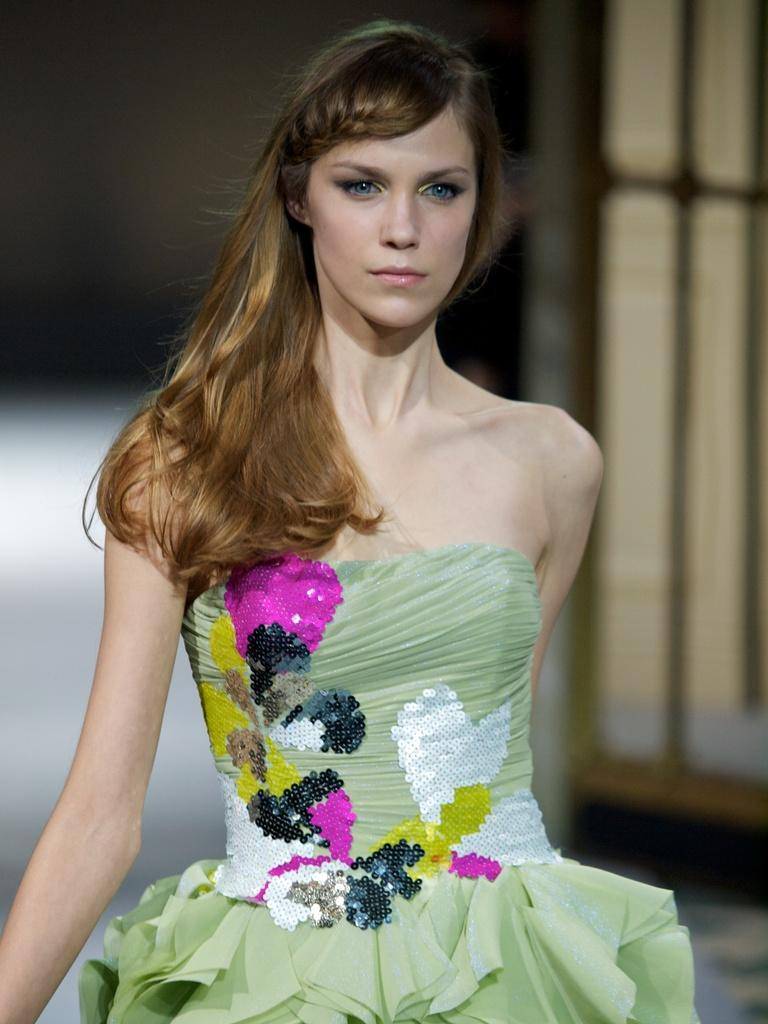Who is the main subject in the foreground of the image? There is a woman in the foreground of the image. What is the woman's position in the image? The woman is on the floor. What can be seen in the background of the image? There is a wall in the background of the image, and the background has a dark color. Can you describe the setting of the image? The image may have been taken on a stage, as suggested by the presence of a wall and the woman's position on the floor. What type of jewel is the woman wearing on her suit in the image? There is no suit or jewel visible in the image; the woman is wearing a dress and is not adorned with any jewelry. 